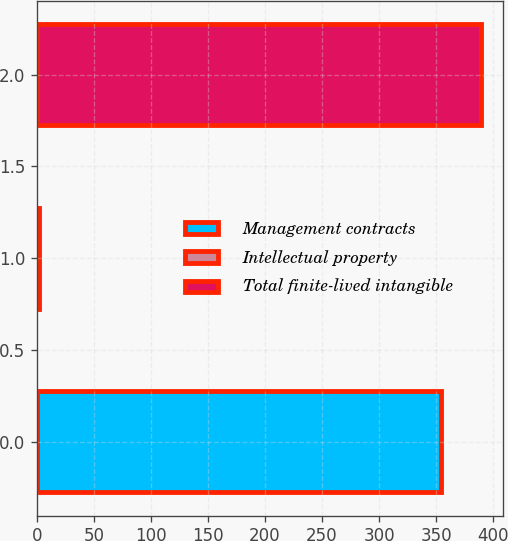<chart> <loc_0><loc_0><loc_500><loc_500><bar_chart><fcel>Management contracts<fcel>Intellectual property<fcel>Total finite-lived intangible<nl><fcel>354<fcel>2<fcel>389.4<nl></chart> 